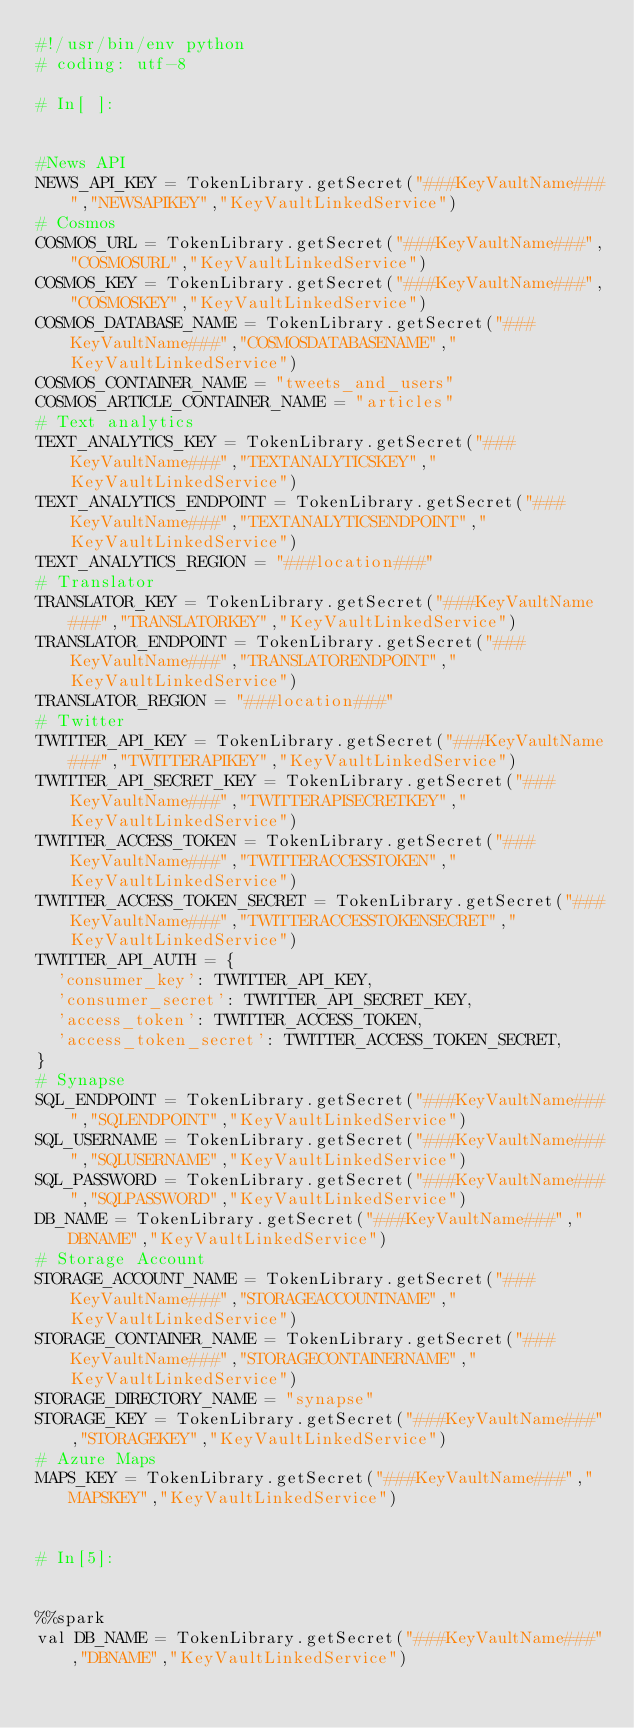<code> <loc_0><loc_0><loc_500><loc_500><_Python_>#!/usr/bin/env python
# coding: utf-8

# In[ ]:


#News API
NEWS_API_KEY = TokenLibrary.getSecret("###KeyVaultName###","NEWSAPIKEY","KeyVaultLinkedService")
# Cosmos
COSMOS_URL = TokenLibrary.getSecret("###KeyVaultName###","COSMOSURL","KeyVaultLinkedService")
COSMOS_KEY = TokenLibrary.getSecret("###KeyVaultName###","COSMOSKEY","KeyVaultLinkedService")
COSMOS_DATABASE_NAME = TokenLibrary.getSecret("###KeyVaultName###","COSMOSDATABASENAME","KeyVaultLinkedService")
COSMOS_CONTAINER_NAME = "tweets_and_users"
COSMOS_ARTICLE_CONTAINER_NAME = "articles"
# Text analytics
TEXT_ANALYTICS_KEY = TokenLibrary.getSecret("###KeyVaultName###","TEXTANALYTICSKEY","KeyVaultLinkedService")
TEXT_ANALYTICS_ENDPOINT = TokenLibrary.getSecret("###KeyVaultName###","TEXTANALYTICSENDPOINT","KeyVaultLinkedService")
TEXT_ANALYTICS_REGION = "###location###"
# Translator
TRANSLATOR_KEY = TokenLibrary.getSecret("###KeyVaultName###","TRANSLATORKEY","KeyVaultLinkedService")
TRANSLATOR_ENDPOINT = TokenLibrary.getSecret("###KeyVaultName###","TRANSLATORENDPOINT","KeyVaultLinkedService")
TRANSLATOR_REGION = "###location###"
# Twitter
TWITTER_API_KEY = TokenLibrary.getSecret("###KeyVaultName###","TWITTERAPIKEY","KeyVaultLinkedService")
TWITTER_API_SECRET_KEY = TokenLibrary.getSecret("###KeyVaultName###","TWITTERAPISECRETKEY","KeyVaultLinkedService")
TWITTER_ACCESS_TOKEN = TokenLibrary.getSecret("###KeyVaultName###","TWITTERACCESSTOKEN","KeyVaultLinkedService")
TWITTER_ACCESS_TOKEN_SECRET = TokenLibrary.getSecret("###KeyVaultName###","TWITTERACCESSTOKENSECRET","KeyVaultLinkedService")
TWITTER_API_AUTH = {
  'consumer_key': TWITTER_API_KEY,
  'consumer_secret': TWITTER_API_SECRET_KEY,
  'access_token': TWITTER_ACCESS_TOKEN,
  'access_token_secret': TWITTER_ACCESS_TOKEN_SECRET,
}
# Synapse
SQL_ENDPOINT = TokenLibrary.getSecret("###KeyVaultName###","SQLENDPOINT","KeyVaultLinkedService")
SQL_USERNAME = TokenLibrary.getSecret("###KeyVaultName###","SQLUSERNAME","KeyVaultLinkedService")
SQL_PASSWORD = TokenLibrary.getSecret("###KeyVaultName###","SQLPASSWORD","KeyVaultLinkedService")
DB_NAME = TokenLibrary.getSecret("###KeyVaultName###","DBNAME","KeyVaultLinkedService")
# Storage Account
STORAGE_ACCOUNT_NAME = TokenLibrary.getSecret("###KeyVaultName###","STORAGEACCOUNTNAME","KeyVaultLinkedService")
STORAGE_CONTAINER_NAME = TokenLibrary.getSecret("###KeyVaultName###","STORAGECONTAINERNAME","KeyVaultLinkedService")
STORAGE_DIRECTORY_NAME = "synapse"
STORAGE_KEY = TokenLibrary.getSecret("###KeyVaultName###","STORAGEKEY","KeyVaultLinkedService")
# Azure Maps
MAPS_KEY = TokenLibrary.getSecret("###KeyVaultName###","MAPSKEY","KeyVaultLinkedService")


# In[5]:


%%spark
val DB_NAME = TokenLibrary.getSecret("###KeyVaultName###","DBNAME","KeyVaultLinkedService")
</code> 